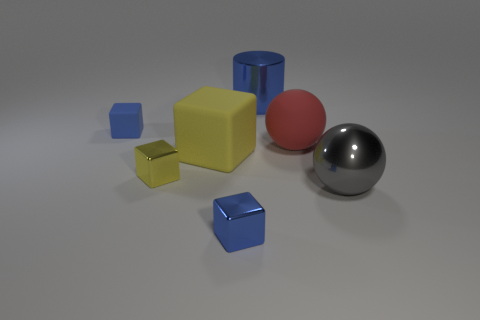Add 3 big cyan cubes. How many objects exist? 10 Subtract all blocks. How many objects are left? 3 Subtract all brown rubber balls. Subtract all red rubber objects. How many objects are left? 6 Add 5 tiny yellow blocks. How many tiny yellow blocks are left? 6 Add 1 tiny brown rubber cubes. How many tiny brown rubber cubes exist? 1 Subtract 0 green blocks. How many objects are left? 7 